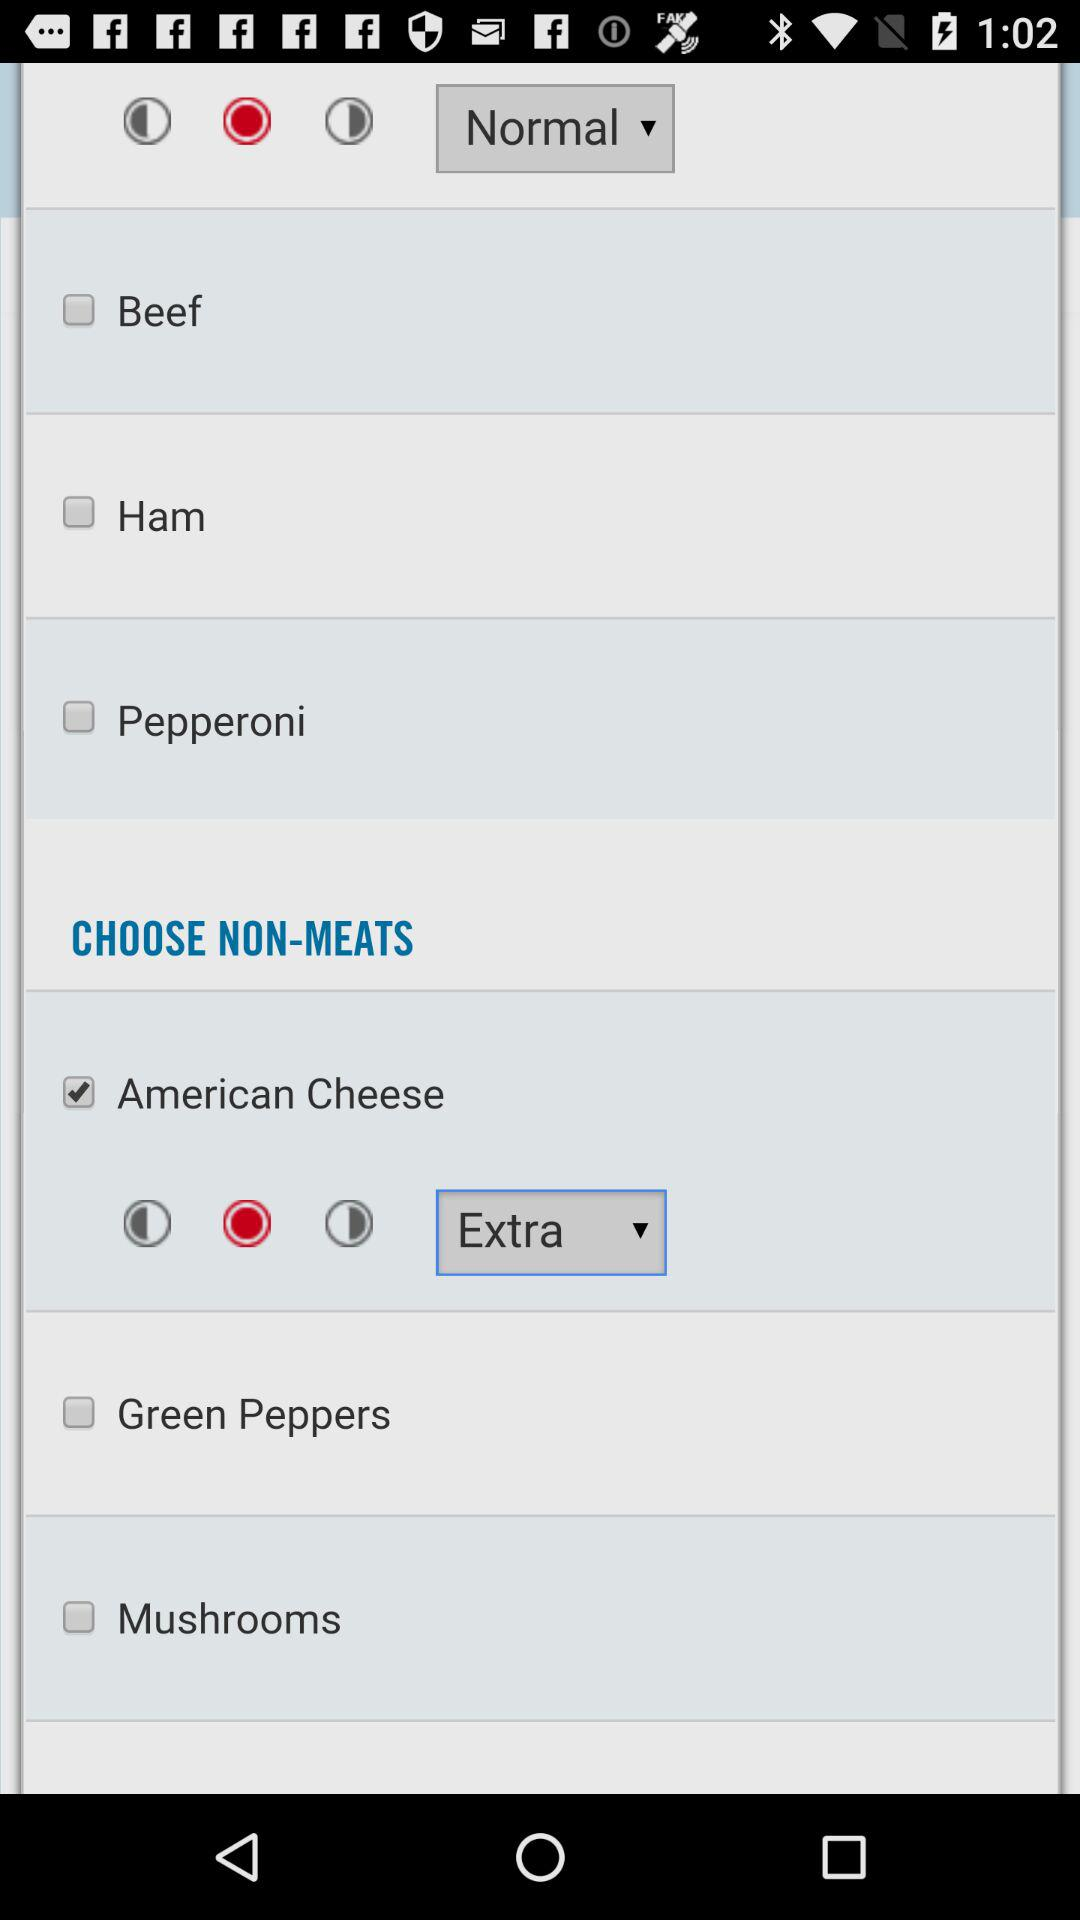Which non-meat is chosen? The chosen non-meat is "American Cheese". 